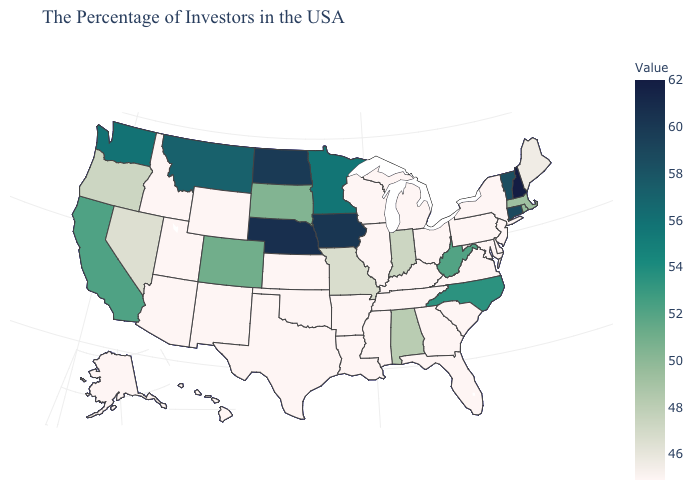Does Utah have the lowest value in the USA?
Give a very brief answer. Yes. Which states have the highest value in the USA?
Concise answer only. New Hampshire. Does Rhode Island have the highest value in the Northeast?
Concise answer only. No. Among the states that border North Dakota , which have the lowest value?
Concise answer only. South Dakota. Does Utah have a lower value than California?
Give a very brief answer. Yes. Is the legend a continuous bar?
Answer briefly. Yes. 